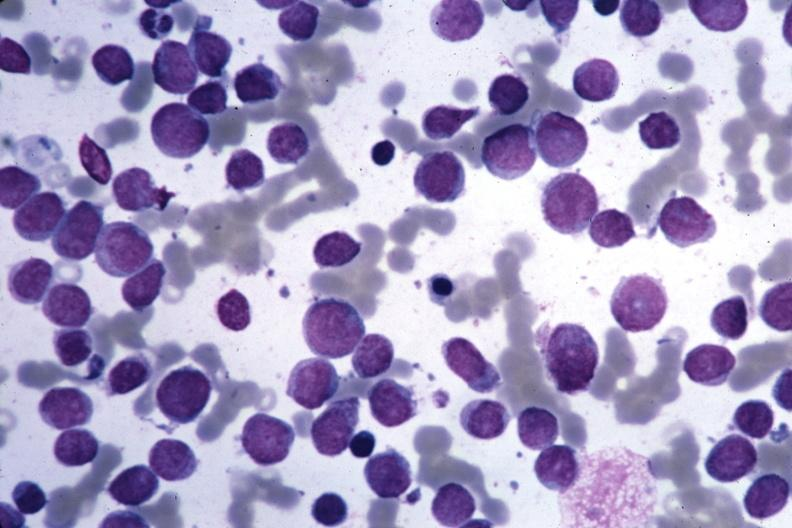how is wrights seen cells?
Answer the question using a single word or phrase. Blastic 